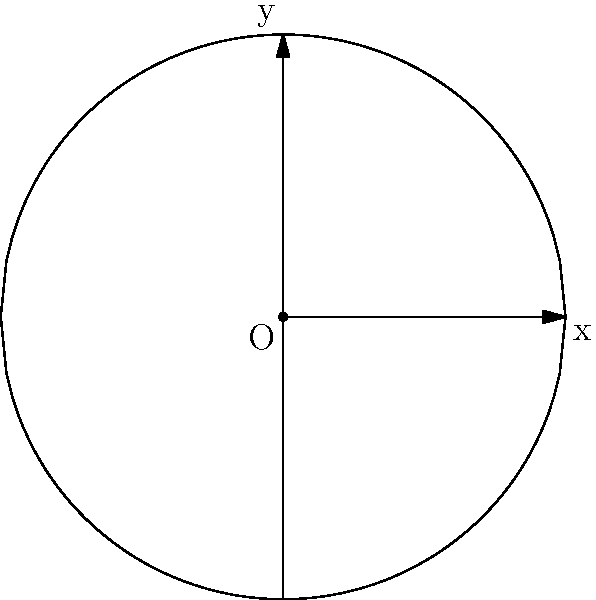As a longtime fan of Jason & the Scorchers, you're helping design an amphitheater for their upcoming reunion concert. The architects propose a semi-circular design for optimal acoustics. Using calculus of variations, determine the curve $y(x)$ that maximizes the enclosed area for a given perimeter length $L$, where the curve is symmetric about the y-axis and connects points $(-a,0)$ and $(a,0)$. What shape does this optimal curve represent? Let's approach this step-by-step using calculus of variations:

1) The area enclosed by the curve is given by the integral:
   $$A = 2\int_0^a y(x) dx$$

2) The arc length (perimeter) is given by:
   $$L = 2\int_0^a \sqrt{1 + (y'(x))^2} dx$$

3) We want to maximize A subject to the constraint of fixed L. This is a variational problem with an isoperimetric constraint.

4) The Euler-Lagrange equation for this problem is:
   $$y'' = \frac{\lambda}{y}$$
   where λ is a constant (Lagrange multiplier).

5) Multiplying both sides by y' and integrating:
   $$\frac{1}{2}(y')^2 = \lambda \ln y + C$$

6) Rearranging:
   $$(y')^2 = 2\lambda \ln y + C'$$

7) This equation represents a circle. To see this, let $y = R\sin\theta$ and $x = R\cos\theta$. Then:
   $$y' = -\cot\theta$$
   $$(y')^2 = \cot^2\theta = \frac{\cos^2\theta}{\sin^2\theta} = \frac{R^2-y^2}{y^2}$$

8) Comparing this with our equation, we see they're equivalent if $R^2 = C'$ and $\lambda = -1$.

9) Therefore, the optimal curve is a circular arc.

This result is known as the isoperimetric inequality: among all closed curves of a given length, the circle encloses the maximum area.
Answer: Circular arc 